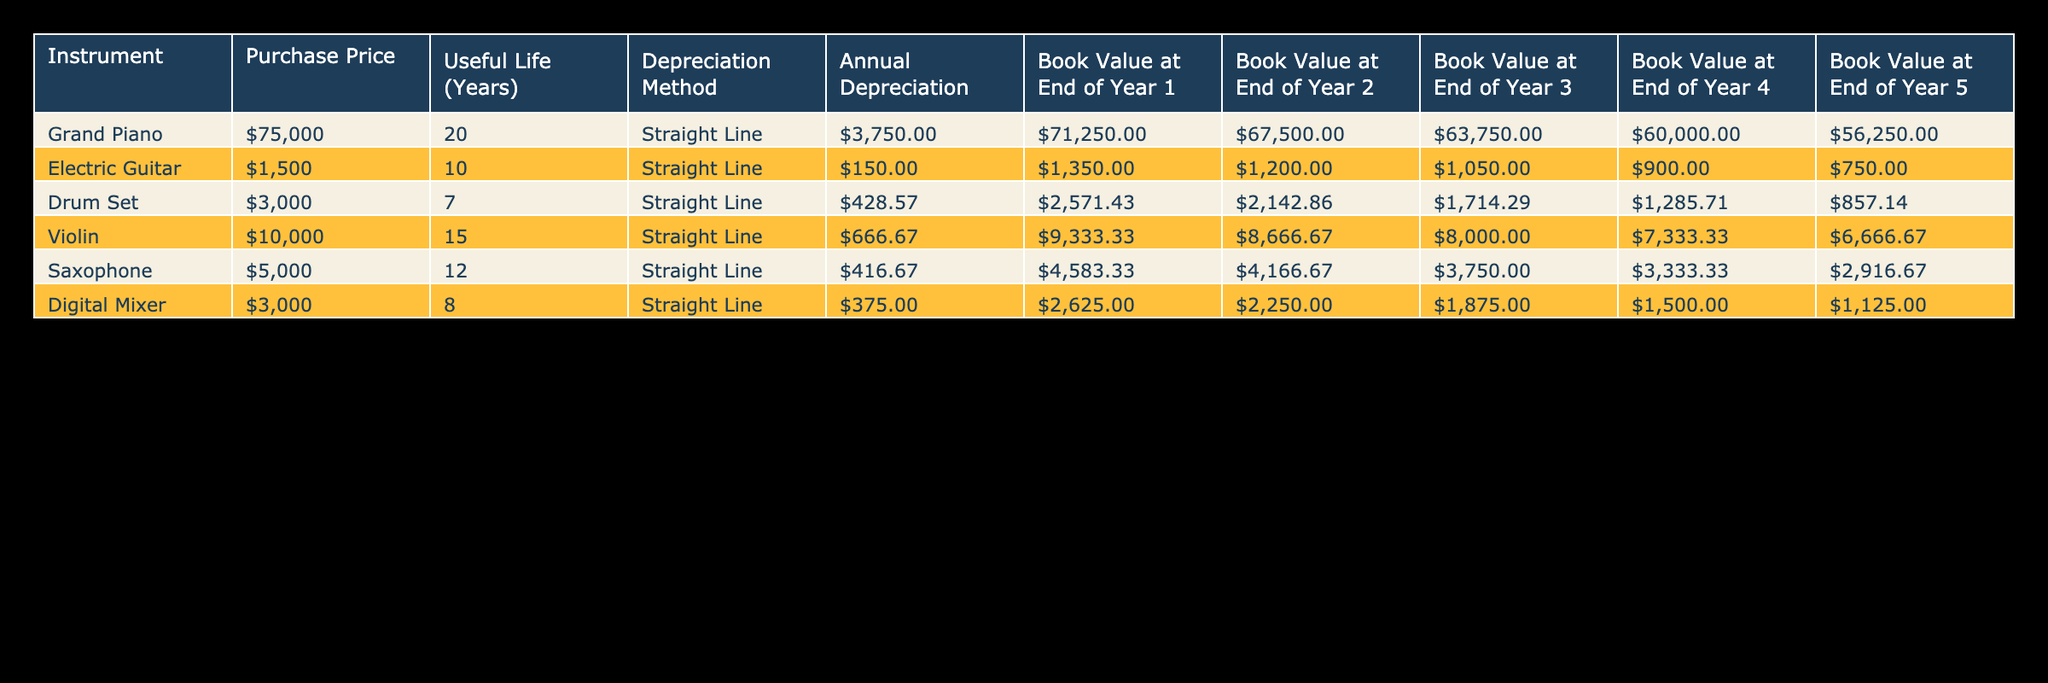What is the purchase price of the Grand Piano? The purchase price of the Grand Piano is listed in the table under the "Purchase Price" column. It shows a value of 75000.
Answer: 75000 What is the annual depreciation of the Electric Guitar? The annual depreciation for the Electric Guitar can be found in the "Annual Depreciation" column for that instrument. The value shown is 150.
Answer: 150 Which instrument has the highest book value at the end of Year 2? To determine which instrument has the highest book value at the end of Year 2, we look at the "Book Value at End of Year 2" column. The values are 67500 for Grand Piano, 1200 for Electric Guitar, 2142.86 for Drum Set, 8666.67 for Violin, 4166.67 for Saxophone, and 2250 for Digital Mixer. The highest value is 67500 belonging to the Grand Piano.
Answer: Grand Piano What is the total depreciation over the useful life of the Drum Set? The total depreciation for the Drum Set can be calculated by multiplying the annual depreciation by its useful life. The annual depreciation is 428.57, and the useful life is 7 years. So, 428.57 * 7 = 3000.
Answer: 3000 Is the Digital Mixer's book value at the end of Year 4 greater than 1500? We check the "Book Value at End of Year 4" for the Digital Mixer, which is 1500. We compare this value to see if it is greater than 1500. Since it is equal to 1500, the answer is no.
Answer: No What is the average annual depreciation of all instruments listed? To find the average annual depreciation, we sum the annual depreciation of all instruments: 3750 + 150 + 428.57 + 666.67 + 416.67 + 375 = 6167.91. Since there are 6 instruments, we divide by 6: 6167.91 / 6 = 1027.99.
Answer: 1027.99 Which instrument has a useful life of 10 years? We scan the "Useful Life (Years)" column to find the value 10. It corresponds to the Electric Guitar, which is clearly listed as having a useful life of 10 years.
Answer: Electric Guitar What is the difference between the book value of the Violin at the end of Year 1 and Year 5? The book value of the Violin at the end of Year 1 is 9333.33, and at the end of Year 5 it is 6666.67. We subtract Year 5 from Year 1: 9333.33 - 6666.67 = 2666.66.
Answer: 2666.66 Is the annual depreciation of the Saxophone less than that of the Electric Guitar? We look at the annual depreciation values: Saxophone has 416.67 and Electric Guitar has 150. Since 416.67 is greater than 150, the answer is no.
Answer: No 